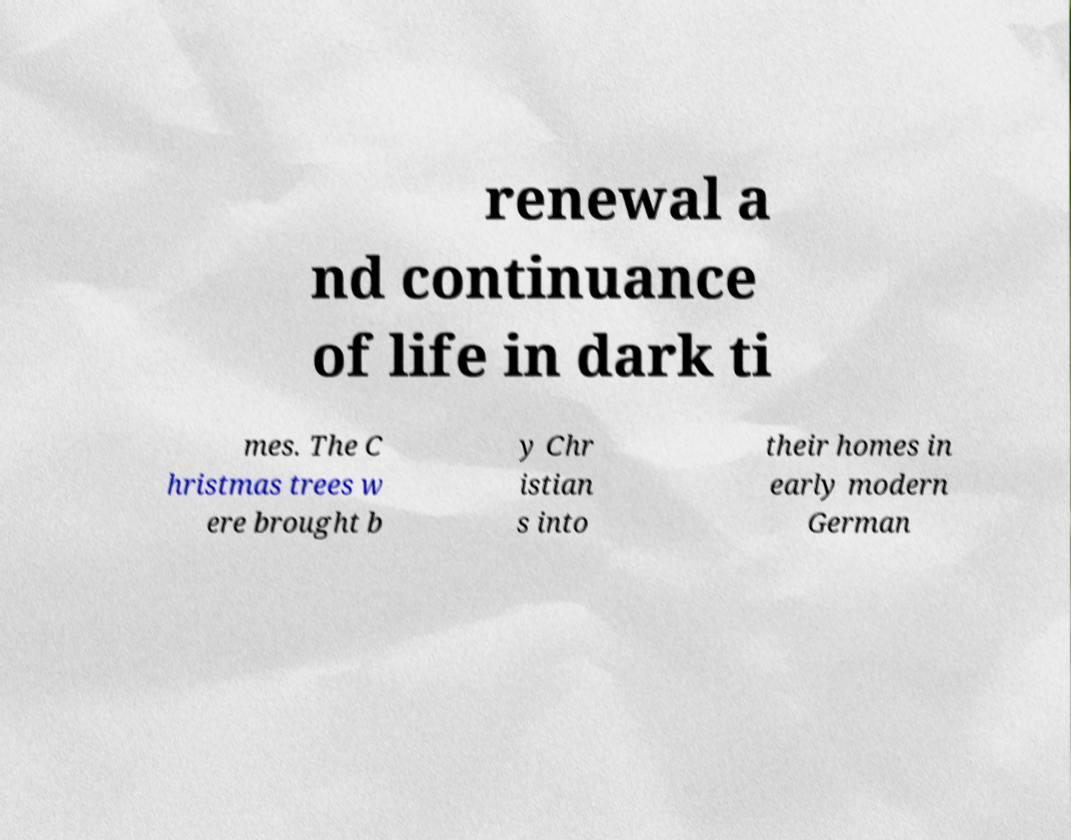Can you accurately transcribe the text from the provided image for me? renewal a nd continuance of life in dark ti mes. The C hristmas trees w ere brought b y Chr istian s into their homes in early modern German 